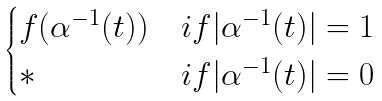<formula> <loc_0><loc_0><loc_500><loc_500>\begin{cases} f ( \alpha ^ { - 1 } ( t ) ) & i f | \alpha ^ { - 1 } ( t ) | = 1 \\ \ast & i f | \alpha ^ { - 1 } ( t ) | = 0 \end{cases}</formula> 